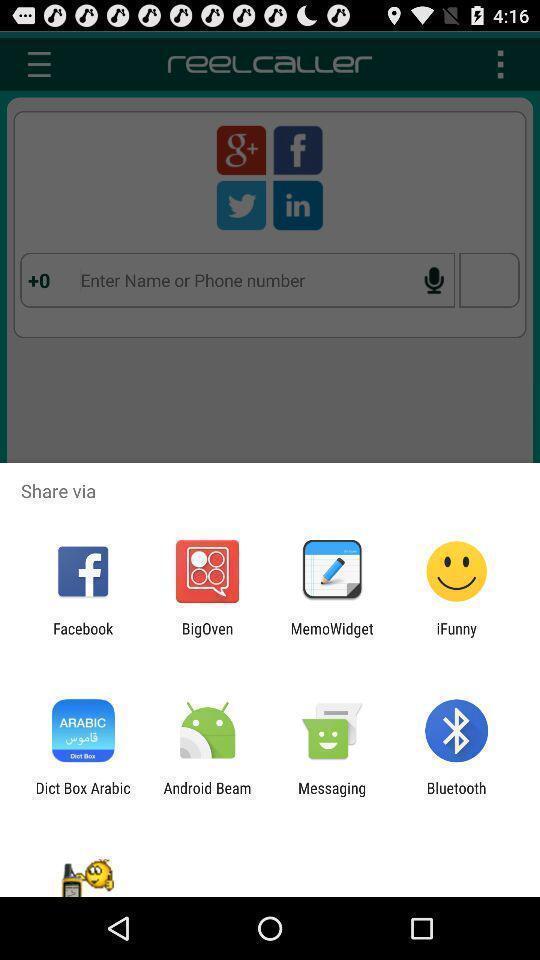Describe the content in this image. Push up page showing app preference to share. 